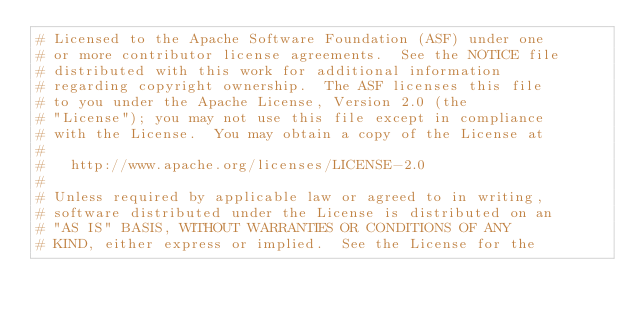<code> <loc_0><loc_0><loc_500><loc_500><_Python_># Licensed to the Apache Software Foundation (ASF) under one
# or more contributor license agreements.  See the NOTICE file
# distributed with this work for additional information
# regarding copyright ownership.  The ASF licenses this file
# to you under the Apache License, Version 2.0 (the
# "License"); you may not use this file except in compliance
# with the License.  You may obtain a copy of the License at
#
#   http://www.apache.org/licenses/LICENSE-2.0
#
# Unless required by applicable law or agreed to in writing,
# software distributed under the License is distributed on an
# "AS IS" BASIS, WITHOUT WARRANTIES OR CONDITIONS OF ANY
# KIND, either express or implied.  See the License for the</code> 